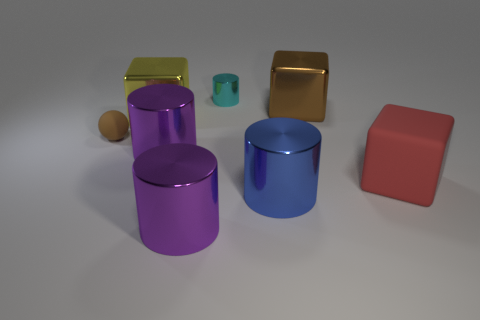There is a tiny matte thing; what shape is it?
Your answer should be very brief. Sphere. There is a large red object that is to the right of the yellow shiny thing; are there any large shiny cubes that are in front of it?
Offer a terse response. No. There is a blue cylinder that is the same size as the yellow block; what material is it?
Offer a very short reply. Metal. Is there a cylinder of the same size as the matte sphere?
Provide a short and direct response. Yes. There is a cylinder in front of the large blue object; what is it made of?
Your response must be concise. Metal. Is the cube that is behind the yellow metallic object made of the same material as the large red block?
Ensure brevity in your answer.  No. The thing that is the same size as the brown sphere is what shape?
Your response must be concise. Cylinder. What number of matte cubes are the same color as the tiny matte thing?
Give a very brief answer. 0. Is the number of shiny blocks right of the large red rubber object less than the number of blue things that are behind the tiny metallic object?
Keep it short and to the point. No. Are there any red matte cubes right of the big matte object?
Your answer should be very brief. No. 